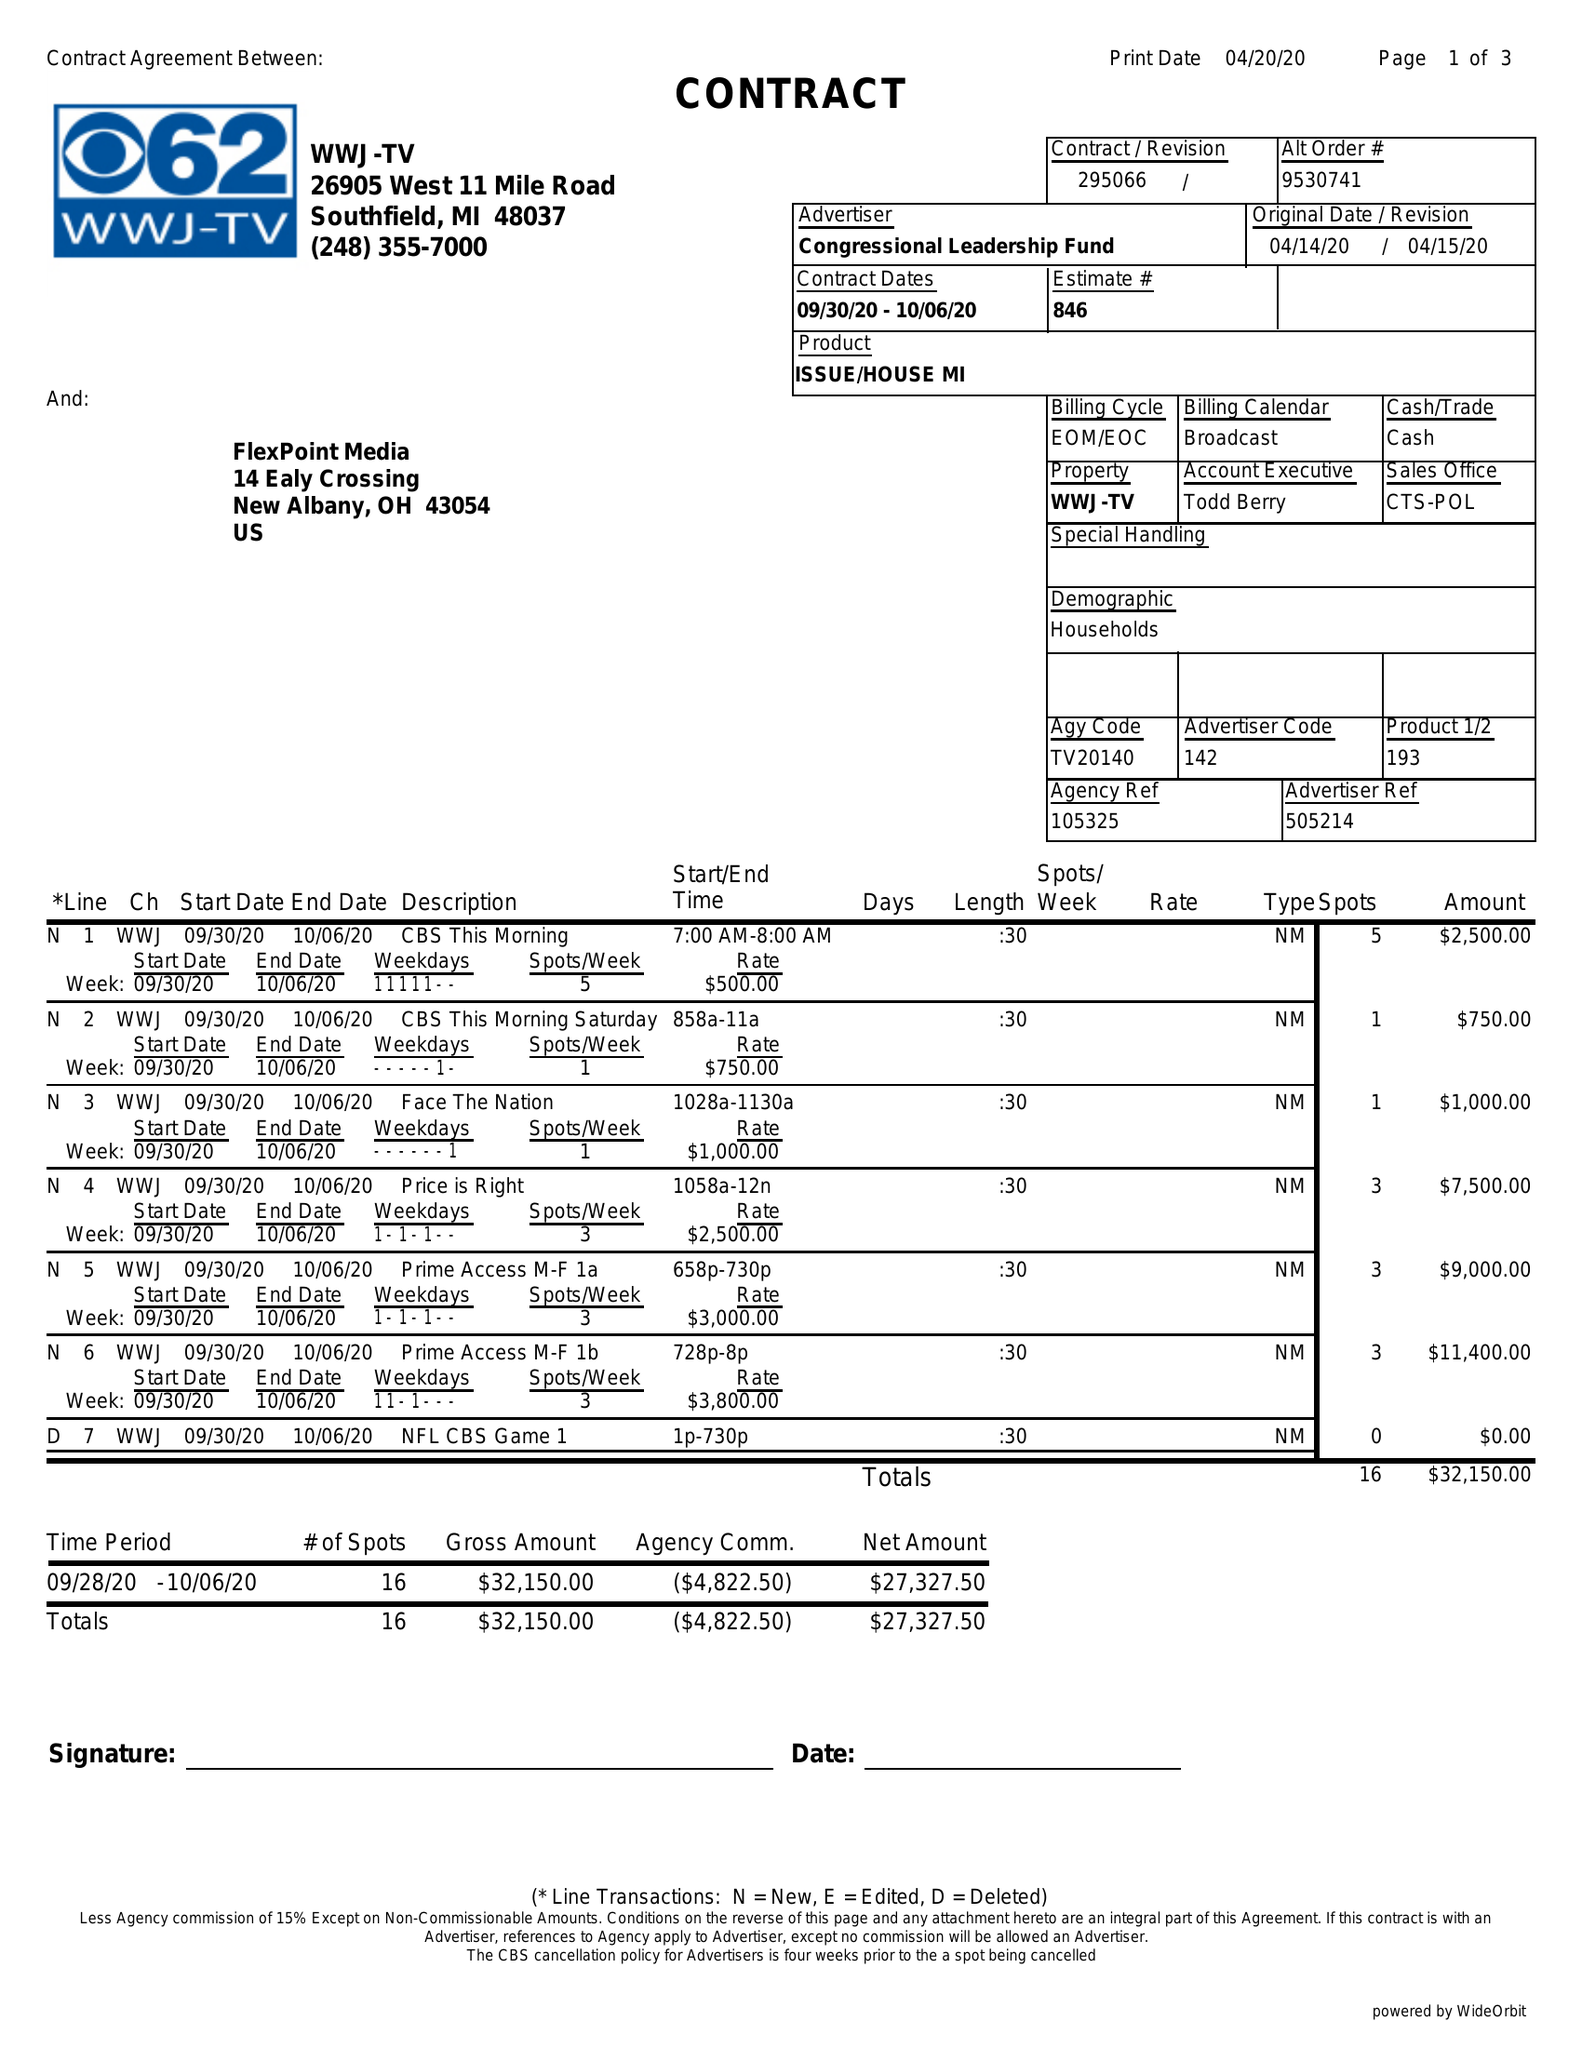What is the value for the contract_num?
Answer the question using a single word or phrase. 295066 